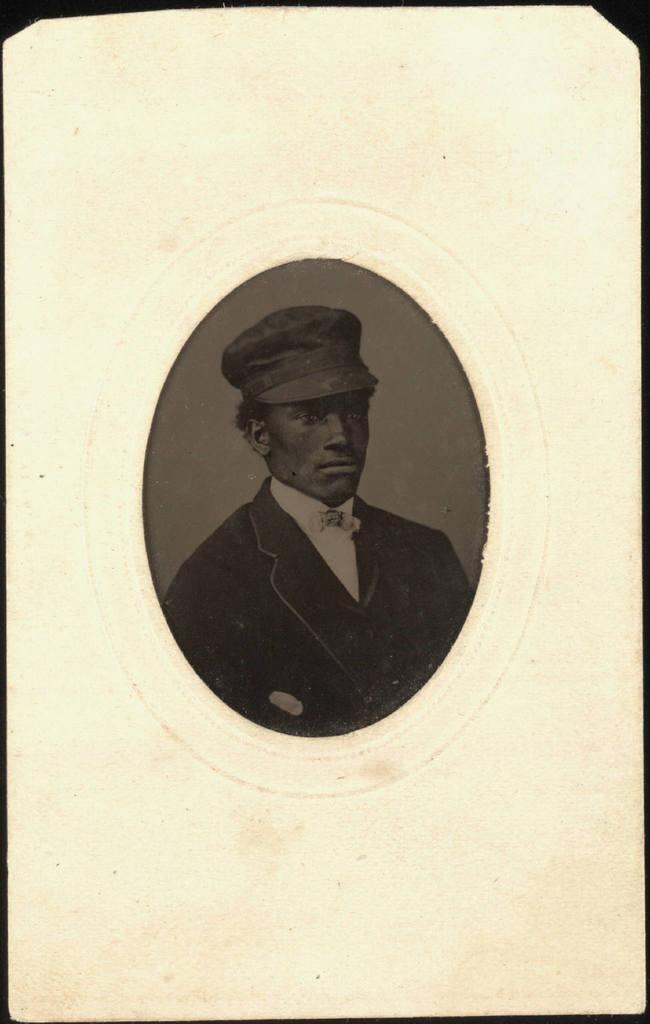Describe this image in one or two sentences. This image looks like a poster. There is a depiction of the person in the foreground. And there is colored background. 